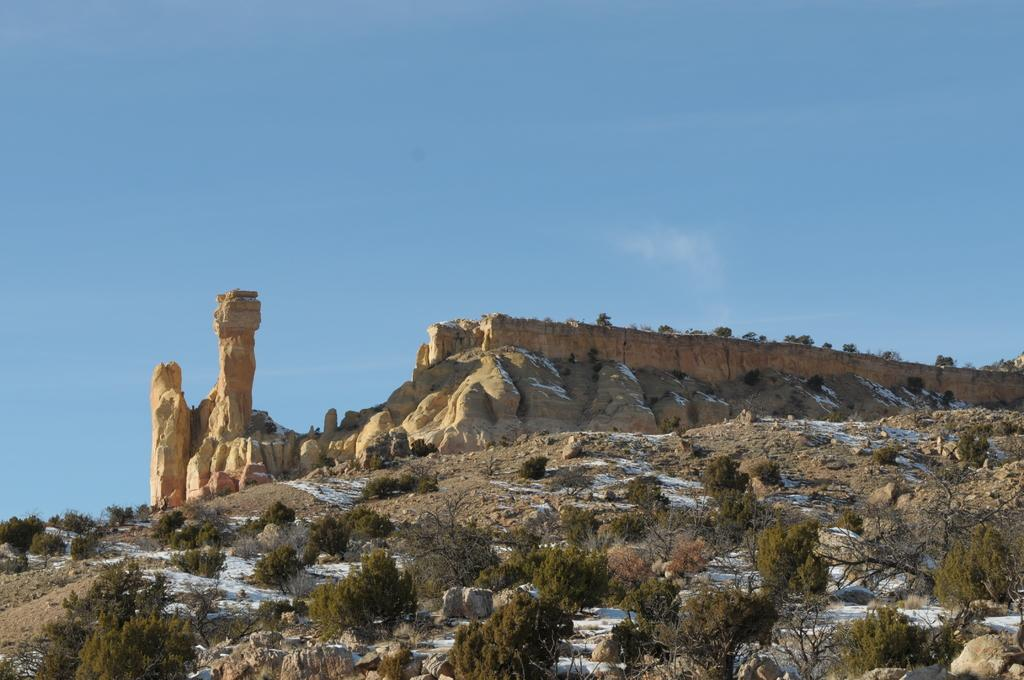What type of natural elements can be seen in the image? There are trees and rocks in the image. What is visible in the background of the image? The sky is visible in the background of the image. How far away is the bomb in the image? There is no bomb present in the image. What type of competition is taking place in the image? There is no competition present in the image. 